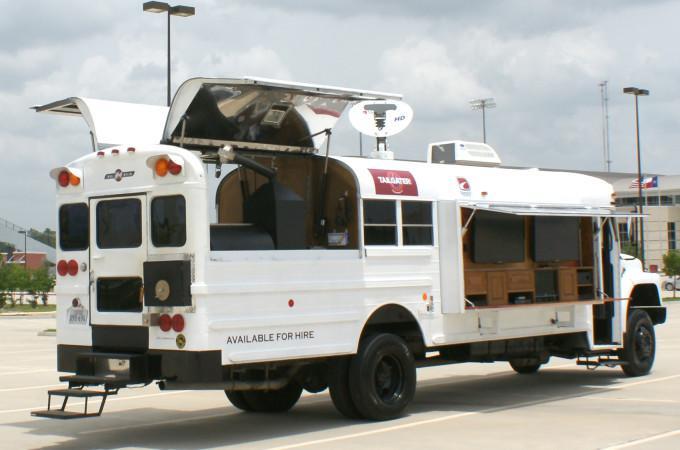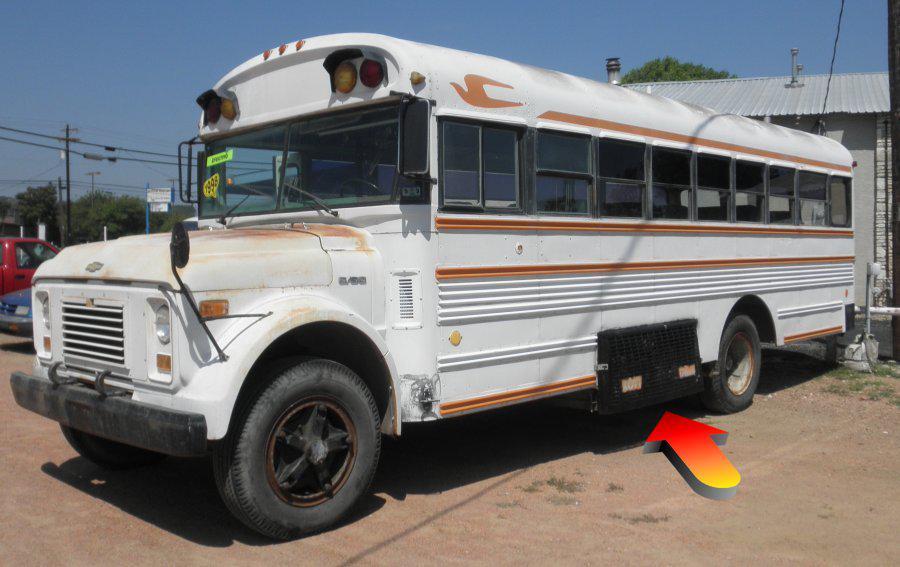The first image is the image on the left, the second image is the image on the right. Assess this claim about the two images: "In at least one image there is a white bus with a flat front hood facing forward right.". Correct or not? Answer yes or no. No. 